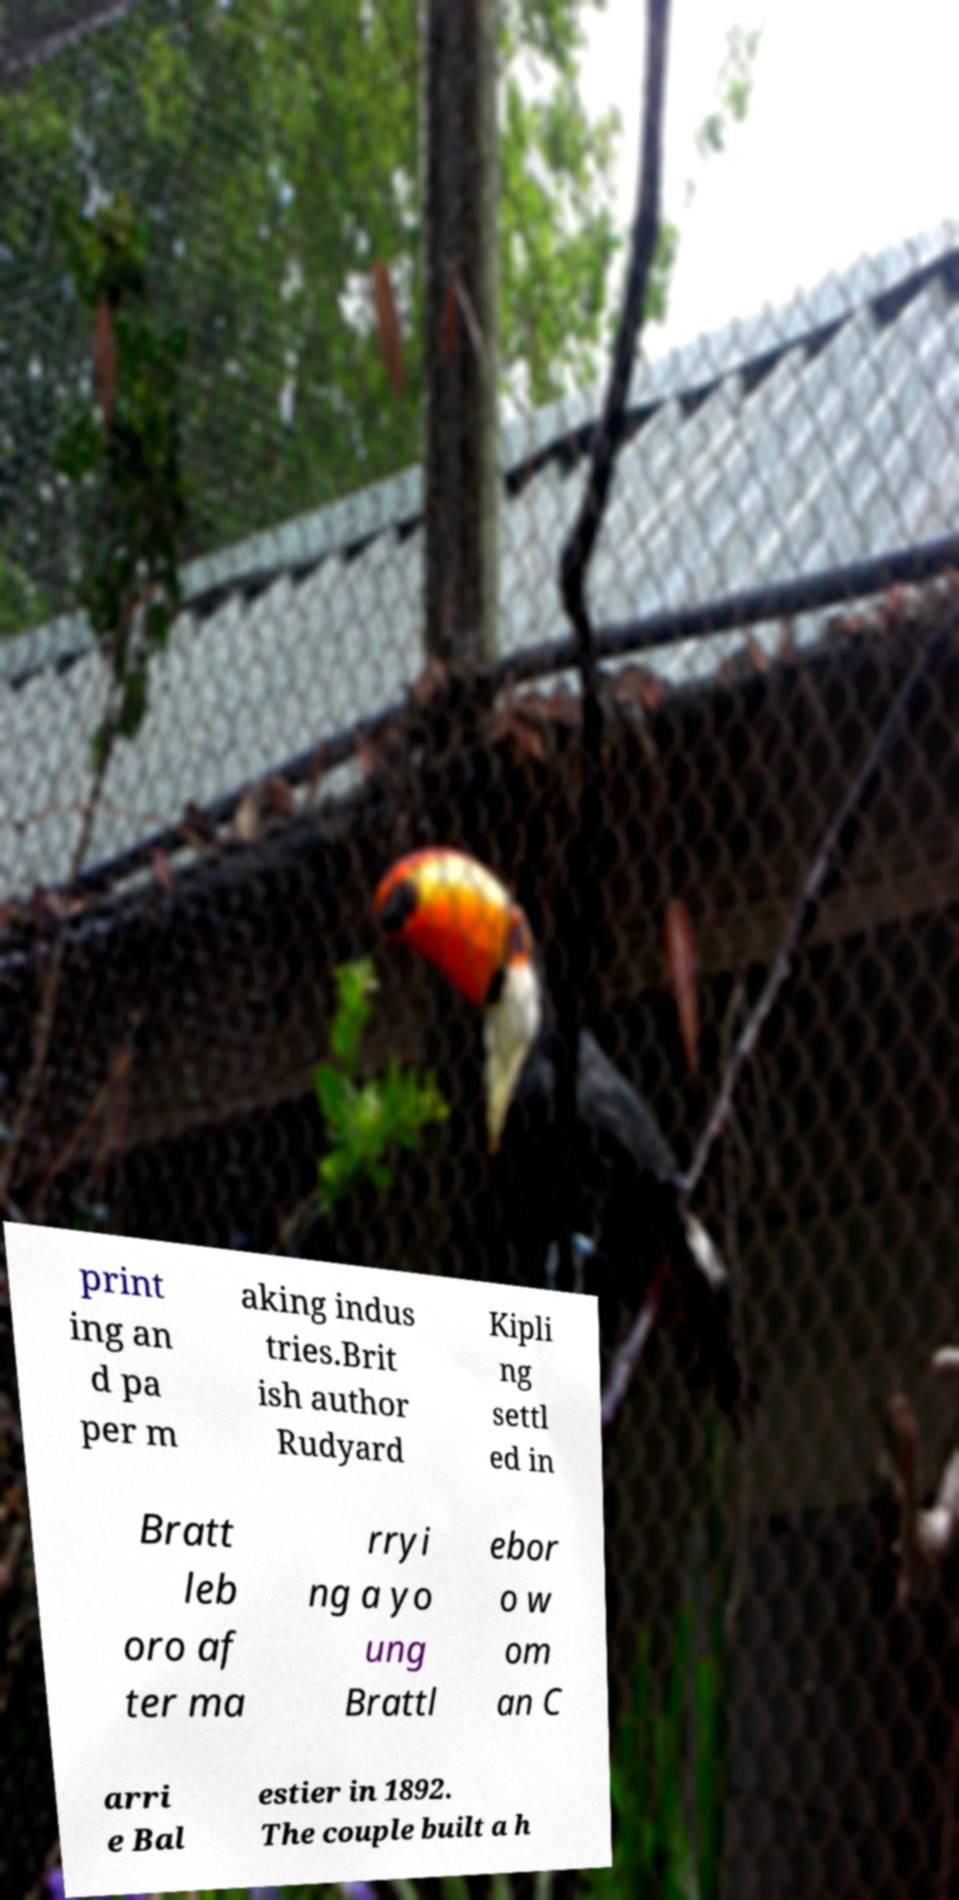Could you assist in decoding the text presented in this image and type it out clearly? print ing an d pa per m aking indus tries.Brit ish author Rudyard Kipli ng settl ed in Bratt leb oro af ter ma rryi ng a yo ung Brattl ebor o w om an C arri e Bal estier in 1892. The couple built a h 